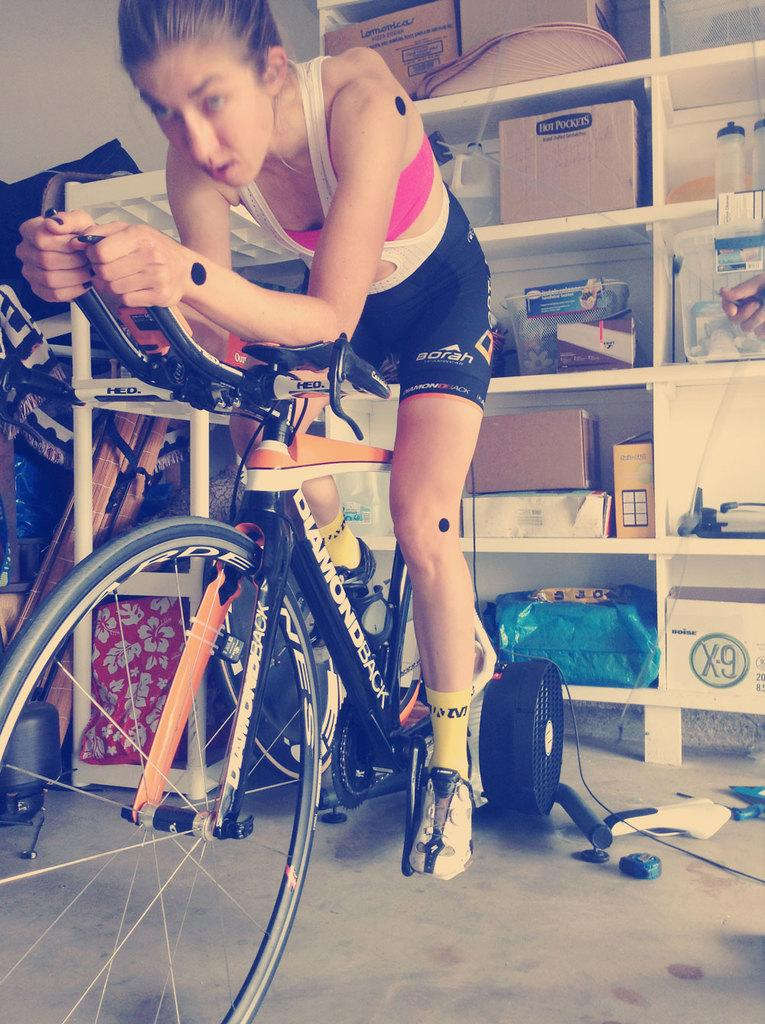Who is the main subject in the image? There is a lady in the image. What is the lady doing in the image? The lady is riding a cycle. What can be seen in the background of the image? There is a rack in the background of the image. What items are stored on the rack? The rack contains cartons, bottles, and other stuff. What type of lawyer is present in the image? There is no lawyer present in the image. How is the railway used in the image? There is no railway present in the image. 